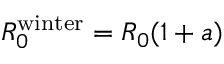<formula> <loc_0><loc_0><loc_500><loc_500>R _ { 0 } ^ { w i n t e r } = R _ { 0 } ( 1 + a )</formula> 